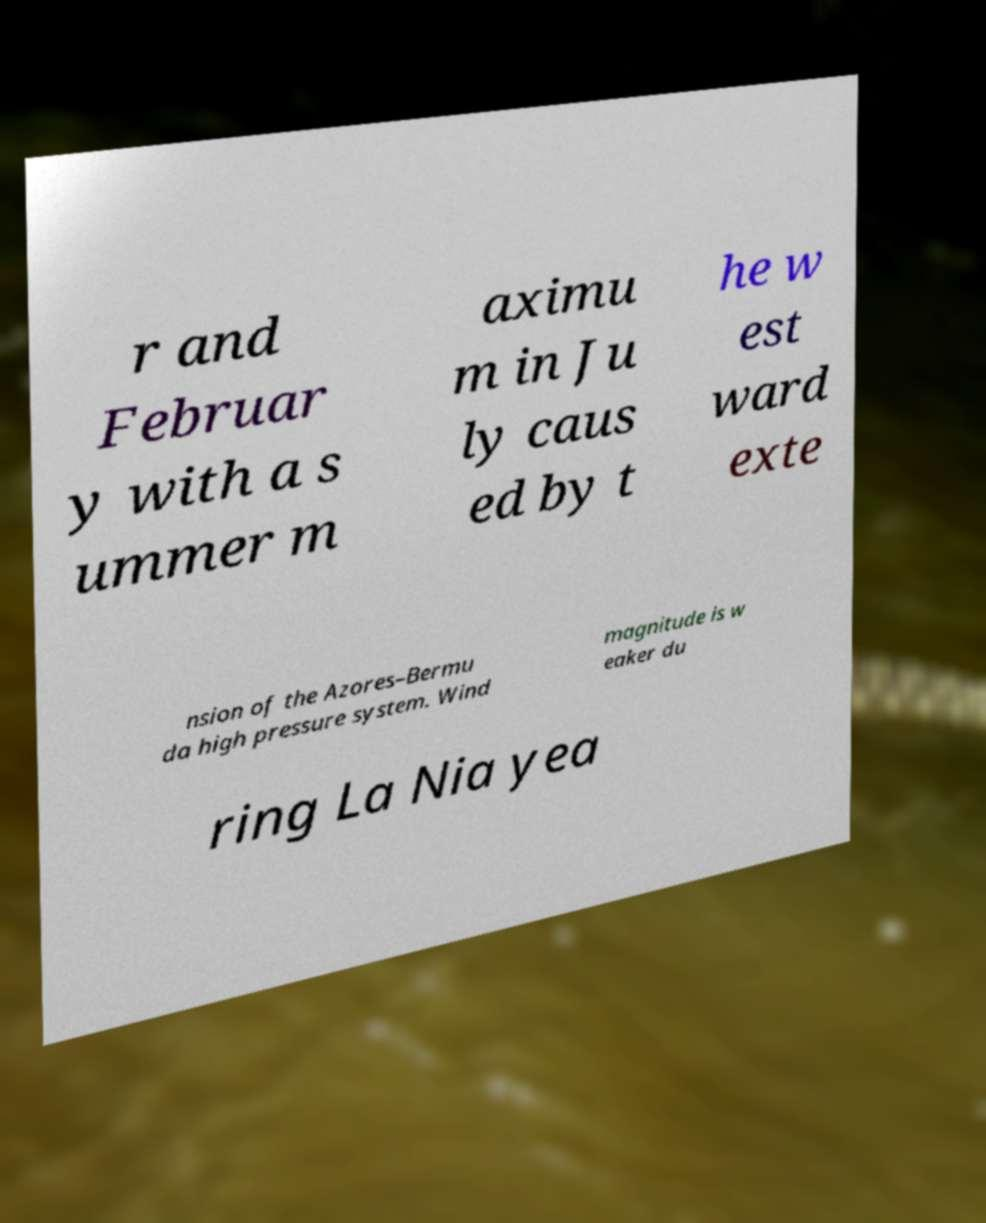Could you assist in decoding the text presented in this image and type it out clearly? r and Februar y with a s ummer m aximu m in Ju ly caus ed by t he w est ward exte nsion of the Azores–Bermu da high pressure system. Wind magnitude is w eaker du ring La Nia yea 